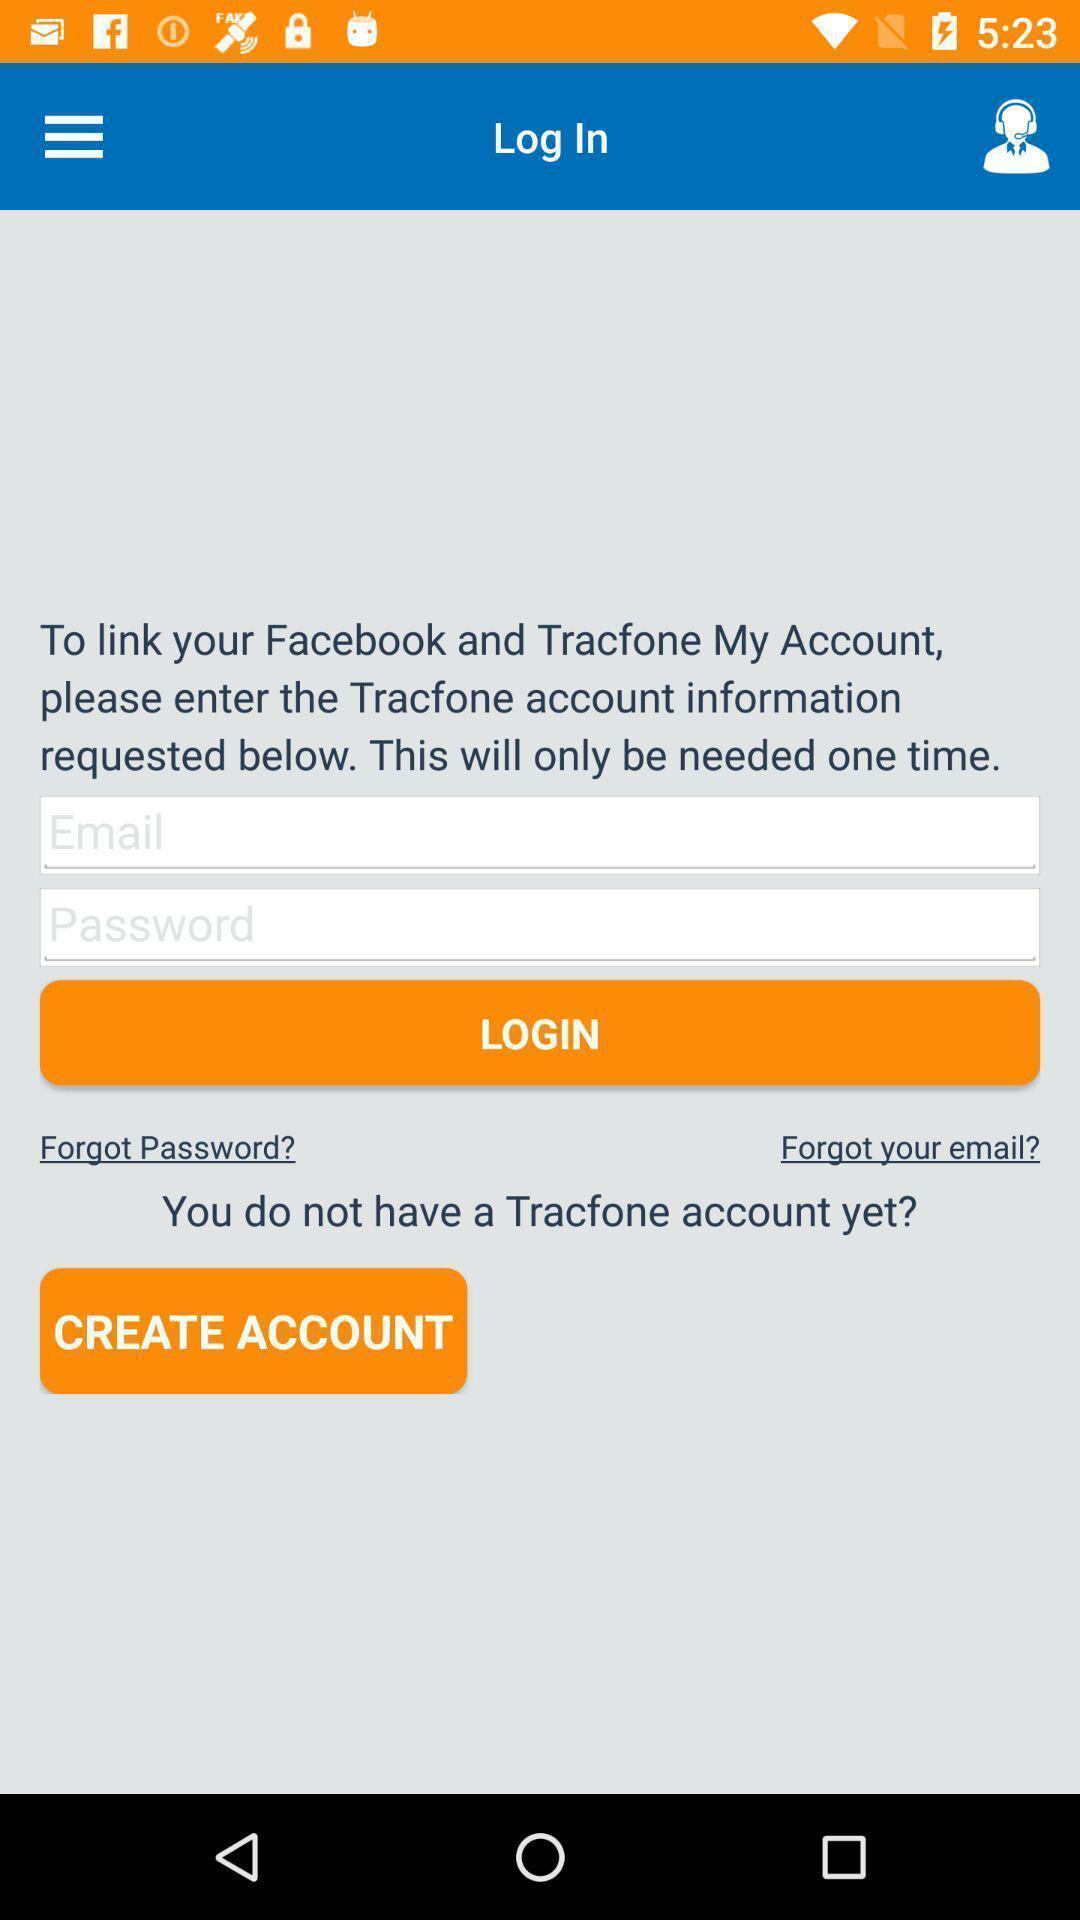Give me a narrative description of this picture. Page displaying information to enter for login or signup. 